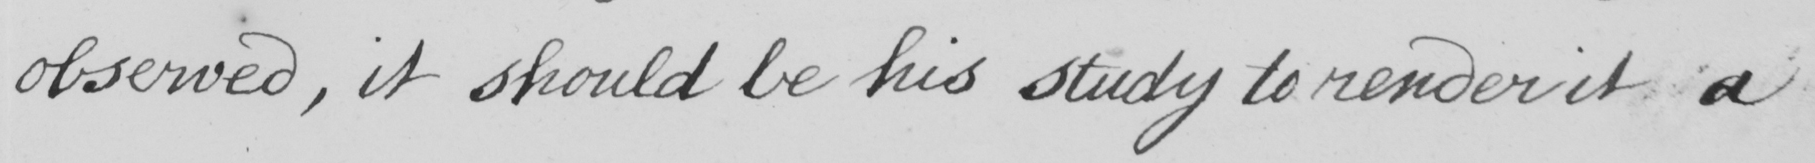Please transcribe the handwritten text in this image. observed , it should be his study to render it a 